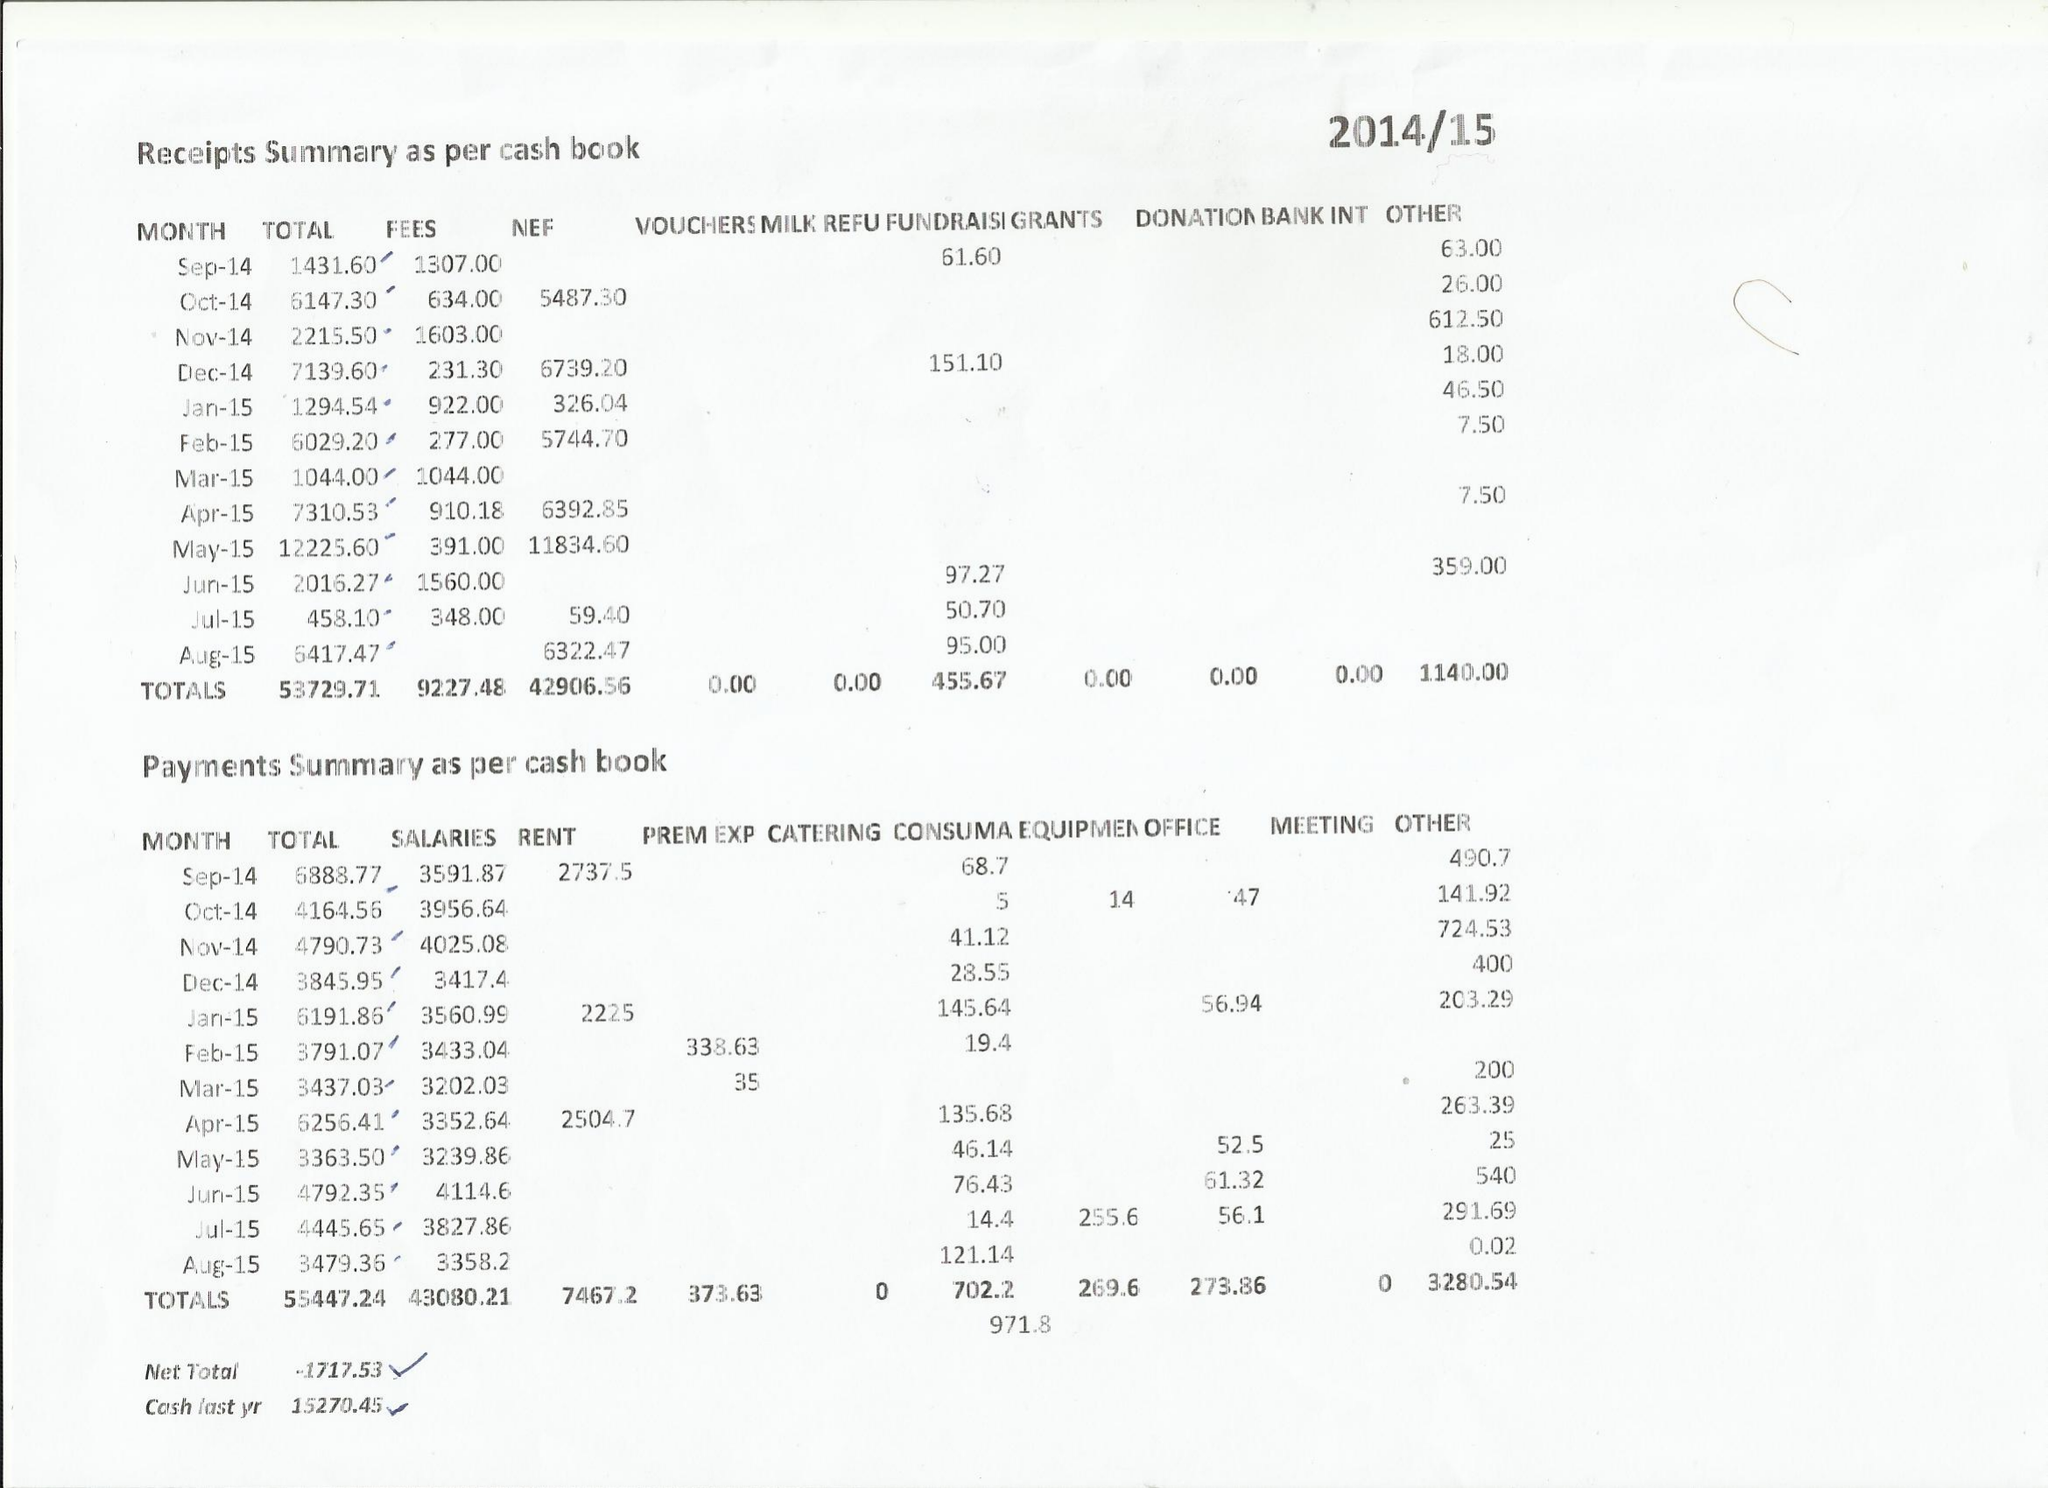What is the value for the income_annually_in_british_pounds?
Answer the question using a single word or phrase. 53730.00 